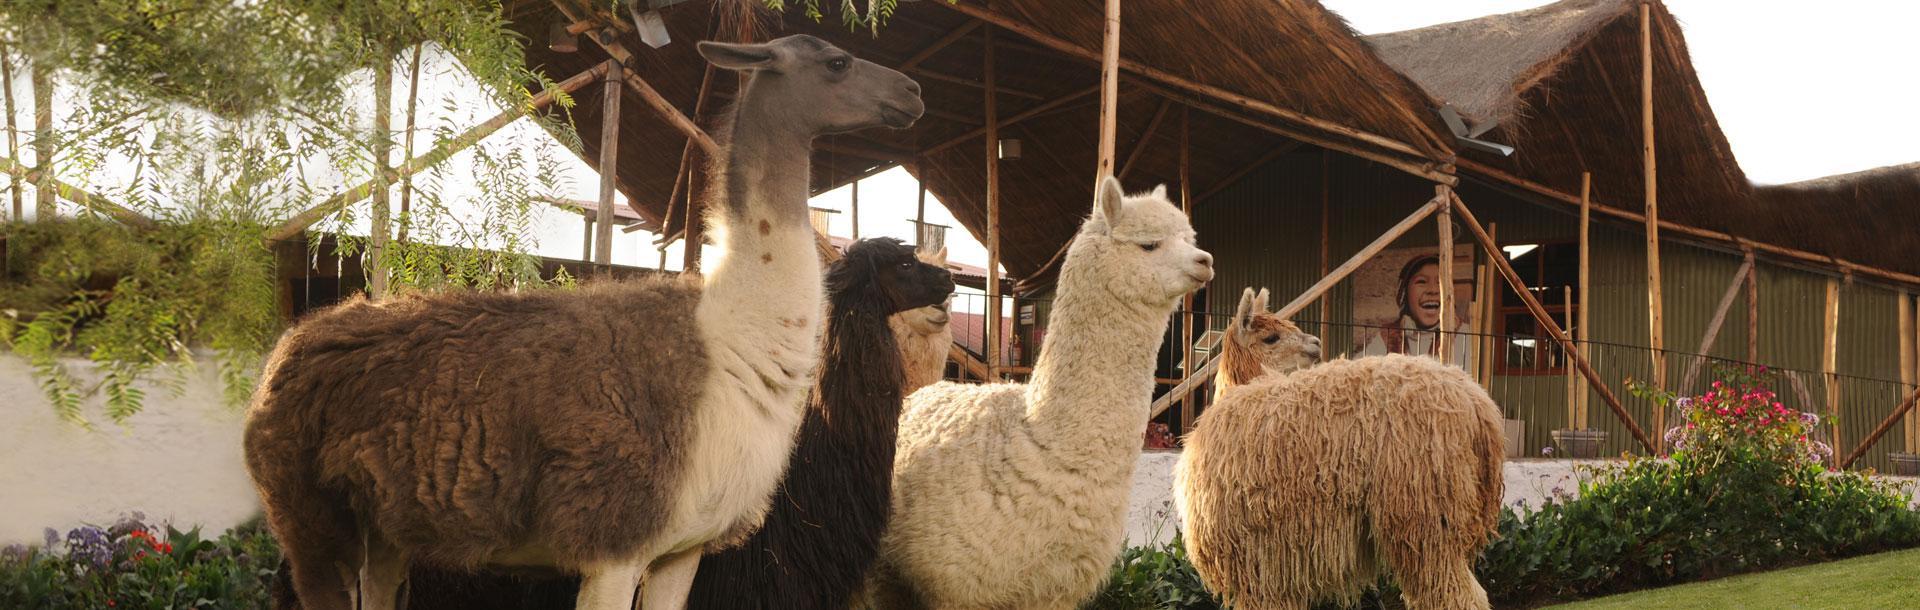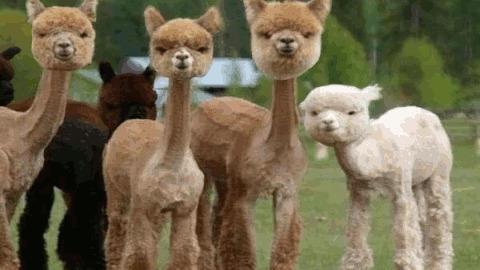The first image is the image on the left, the second image is the image on the right. Given the left and right images, does the statement "At least one person is standing outside with the animals in one of the images." hold true? Answer yes or no. No. The first image is the image on the left, the second image is the image on the right. Examine the images to the left and right. Is the description "One image shows a close-together group of several llamas with bodies turned forward, and the other image includes a person standing to the right of and looking at a llama while holding a rope attached to it." accurate? Answer yes or no. No. 